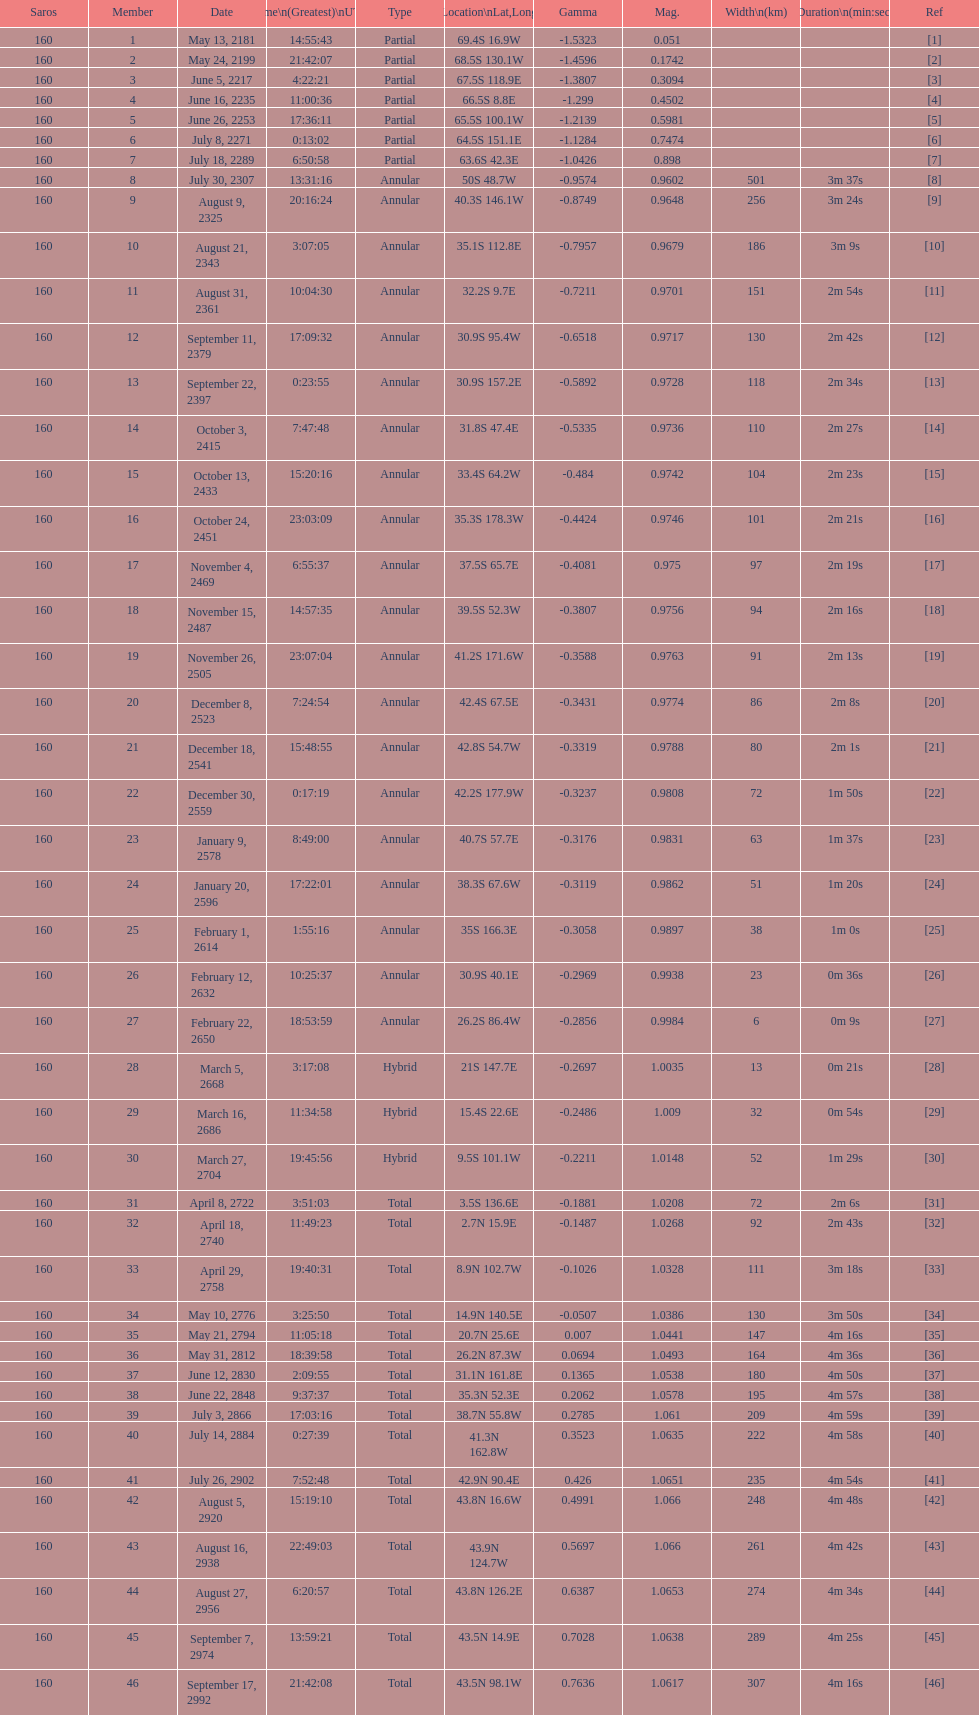How long did 18 last? 2m 16s. 